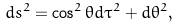Convert formula to latex. <formula><loc_0><loc_0><loc_500><loc_500>d s ^ { 2 } = \cos ^ { 2 } \theta d \tau ^ { 2 } + d \theta ^ { 2 } ,</formula> 